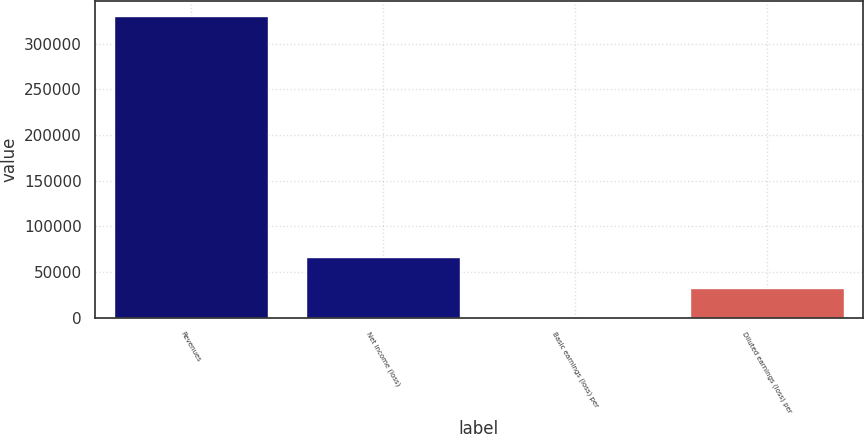Convert chart to OTSL. <chart><loc_0><loc_0><loc_500><loc_500><bar_chart><fcel>Revenues<fcel>Net income (loss)<fcel>Basic earnings (loss) per<fcel>Diluted earnings (loss) per<nl><fcel>330292<fcel>66058.6<fcel>0.3<fcel>33029.5<nl></chart> 